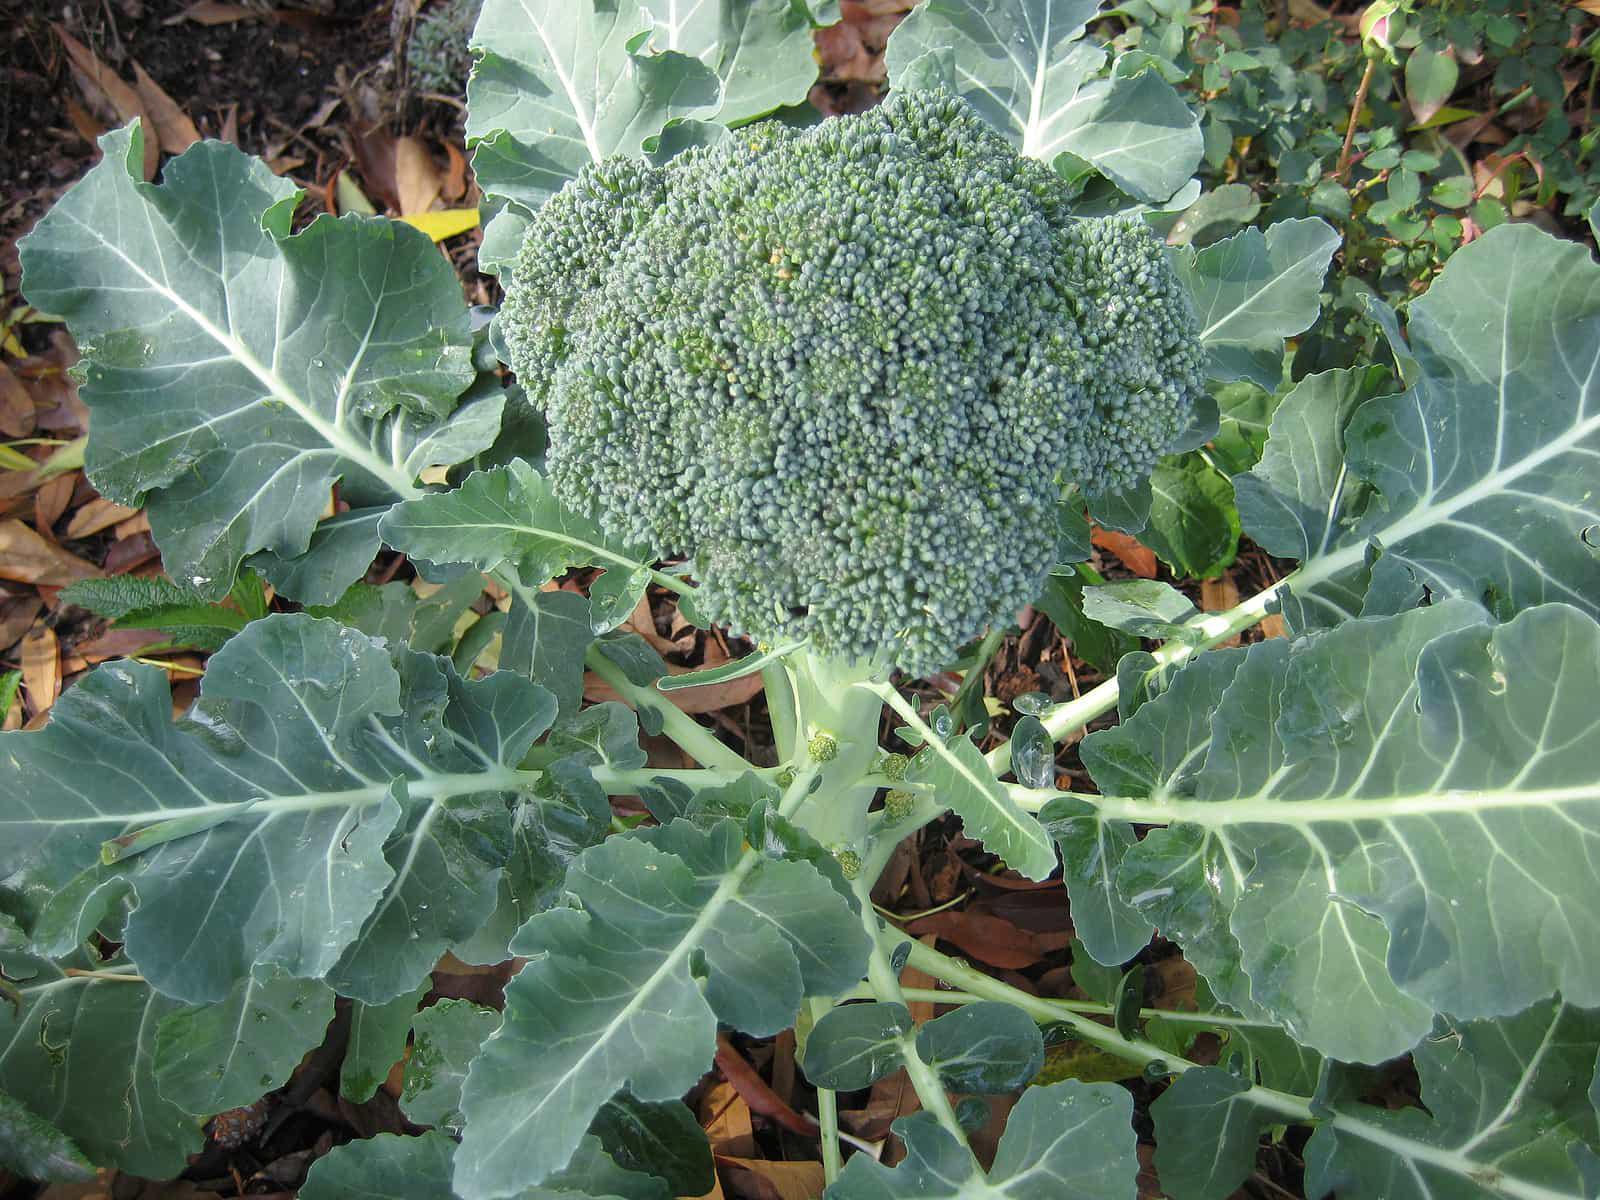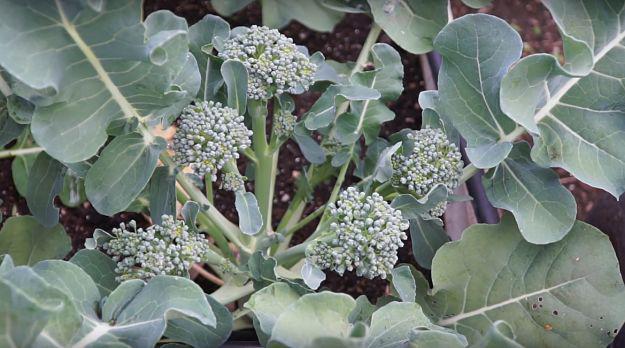The first image is the image on the left, the second image is the image on the right. Assess this claim about the two images: "The left and right image contains the same number of head of broccoli.". Correct or not? Answer yes or no. No. The first image is the image on the left, the second image is the image on the right. Considering the images on both sides, is "There are three separate broccoli branches." valid? Answer yes or no. No. 